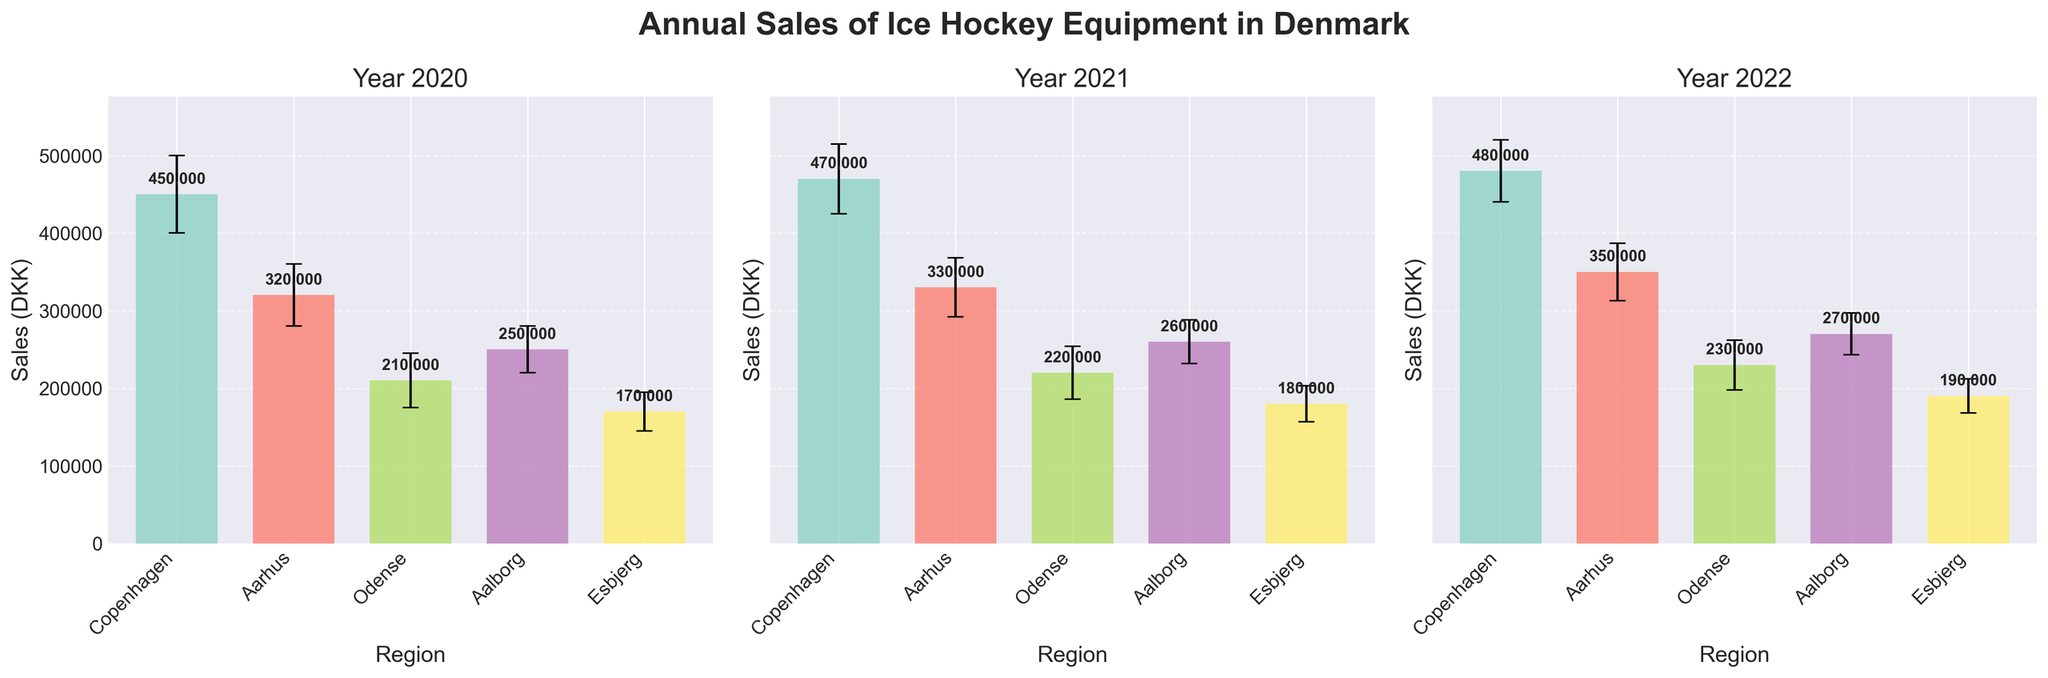How many regions are represented in the figure? There are five different regions listed on the x-axis of each subplot: Copenhagen, Aarhus, Odense, Aalborg, and Esbjerg.
Answer: 5 Which year had the highest average sales in Copenhagen? By comparing the average sales bars for Copenhagen across the three subplots, the 2022 subplot contains the highest bar with an average sales of 480,000 DKK.
Answer: 2022 What is the difference in average sales between Odense and Aalborg in 2021? Referring to the 2021 subplot, the average sales for Odense is 220,000 DKK and for Aalborg is 260,000 DKK. The difference is 260,000 - 220,000 = 40,000 DKK.
Answer: 40,000 DKK Which region consistently has the lowest average sales over the three years? By comparing the heights of the bars for each region across the three subplots, Esbjerg consistently has the lowest average sales: 170,000 DKK in 2020, 180,000 DKK in 2021, and 190,000 DKK in 2022.
Answer: Esbjerg What is the total average sales for all regions in 2020? Adding the average sales of all regions in the 2020 subplot: 450,000 (Copenhagen) + 320,000 (Aarhus) + 210,000 (Odense) + 250,000 (Aalborg) + 170,000 (Esbjerg) = 1,400,000 DKK.
Answer: 1,400,000 DKK In which year did Aarhus see the greatest increase in average sales compared to the previous year? From the subplots: 2020 to 2021 Aarhus sales increase = 330,000 - 320,000 = 10,000 DKK. 2021 to 2022 Aarhus sales increase = 350,000 - 330,000 = 20,000 DKK. Thus, the greatest increase is from 2021 to 2022.
Answer: 2021 to 2022 Which year has the smallest variation (standard deviation) in average sales for any region? By comparing the standard deviation error bars on the subplots, the smallest variation for any region is Esbjerg in 2022 with a standard deviation of 22,000 DKK.
Answer: 2022 How do the average sales in Aalborg change from 2020 to 2022? Looking at the bars for Aalborg across the subplots: 250,000 DKK in 2020, 260,000 DKK in 2021, and 270,000 DKK in 2022. The sales steadily increase every year.
Answer: Increased steadily What is the total average sales for all regions in 2022? Adding the average sales of all regions in the 2022 subplot: 480,000 (Copenhagen) + 350,000 (Aarhus) + 230,000 (Odense) + 270,000 (Aalborg) + 190,000 (Esbjerg) = 1,520,000 DKK.
Answer: 1,520,000 DKK 